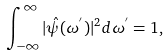Convert formula to latex. <formula><loc_0><loc_0><loc_500><loc_500>\int _ { - \infty } ^ { \infty } | \hat { \psi } ( \omega ^ { ^ { \prime } } ) | ^ { 2 } d \omega ^ { ^ { \prime } } = 1 ,</formula> 